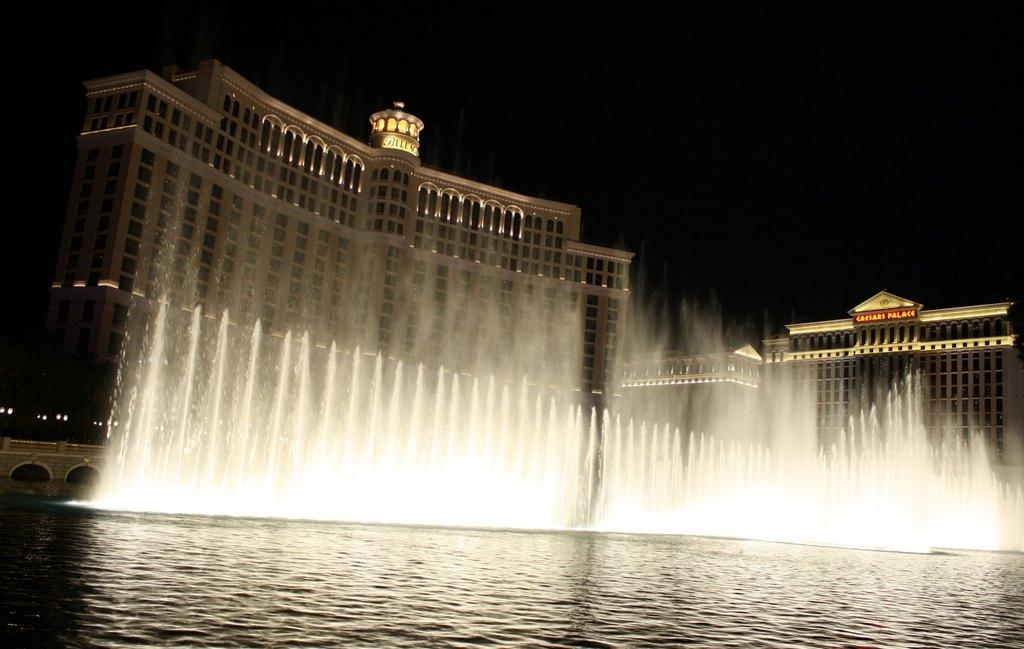What is the main subject of the image? The main subject of the image is a water fountain. Can you describe the water in the image? Yes, there is water visible in the image. What can be seen in the background of the image? There are buildings and the sky visible in the background of the image. Can you tell me how many balloons are floating in the water fountain in the image? There are no balloons present in the image; it features a water fountain with water. What type of twig is visible growing from the water fountain in the image? There is no twig growing from the water fountain in the image. 